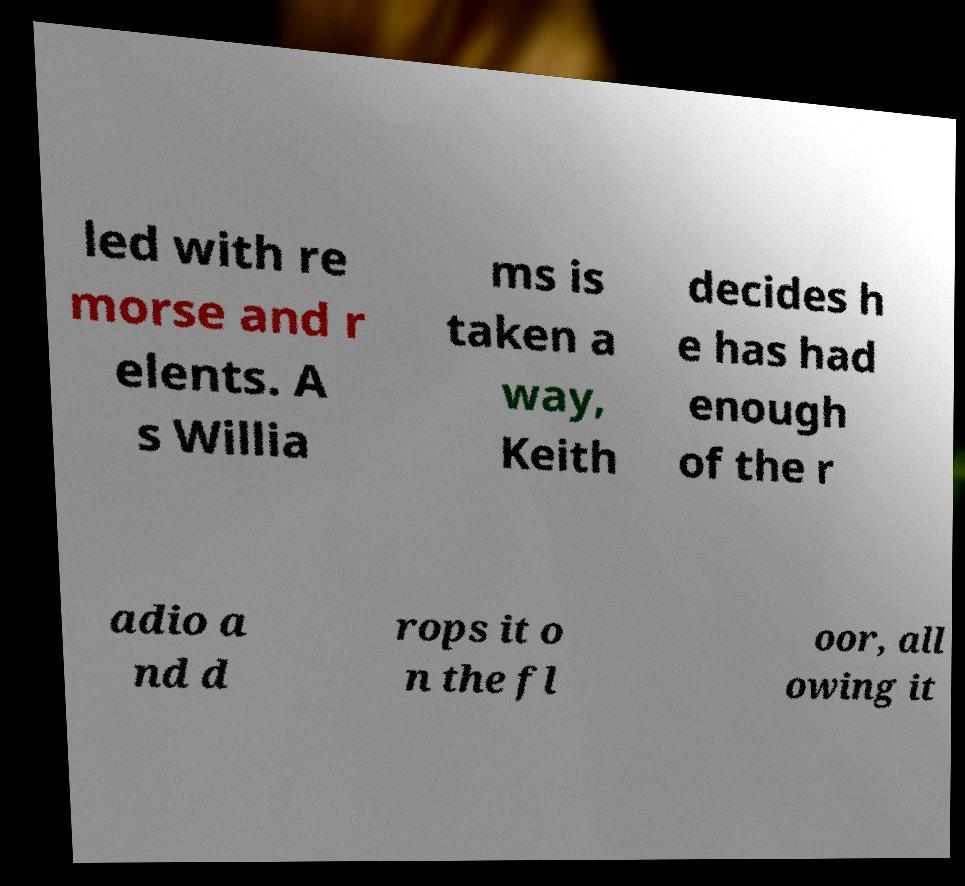Could you extract and type out the text from this image? led with re morse and r elents. A s Willia ms is taken a way, Keith decides h e has had enough of the r adio a nd d rops it o n the fl oor, all owing it 